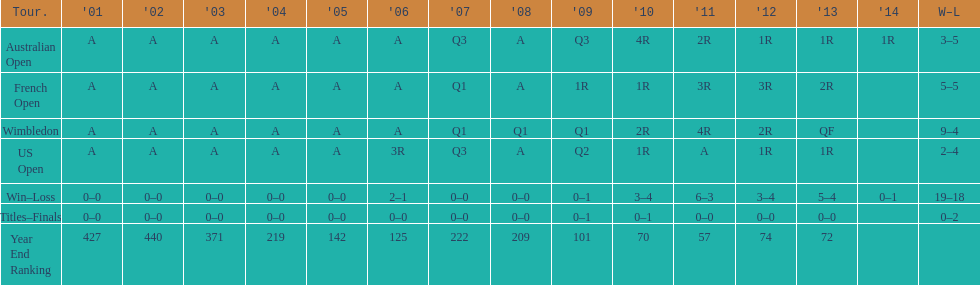Which competition holds the record for the highest overall victory? Wimbledon. 